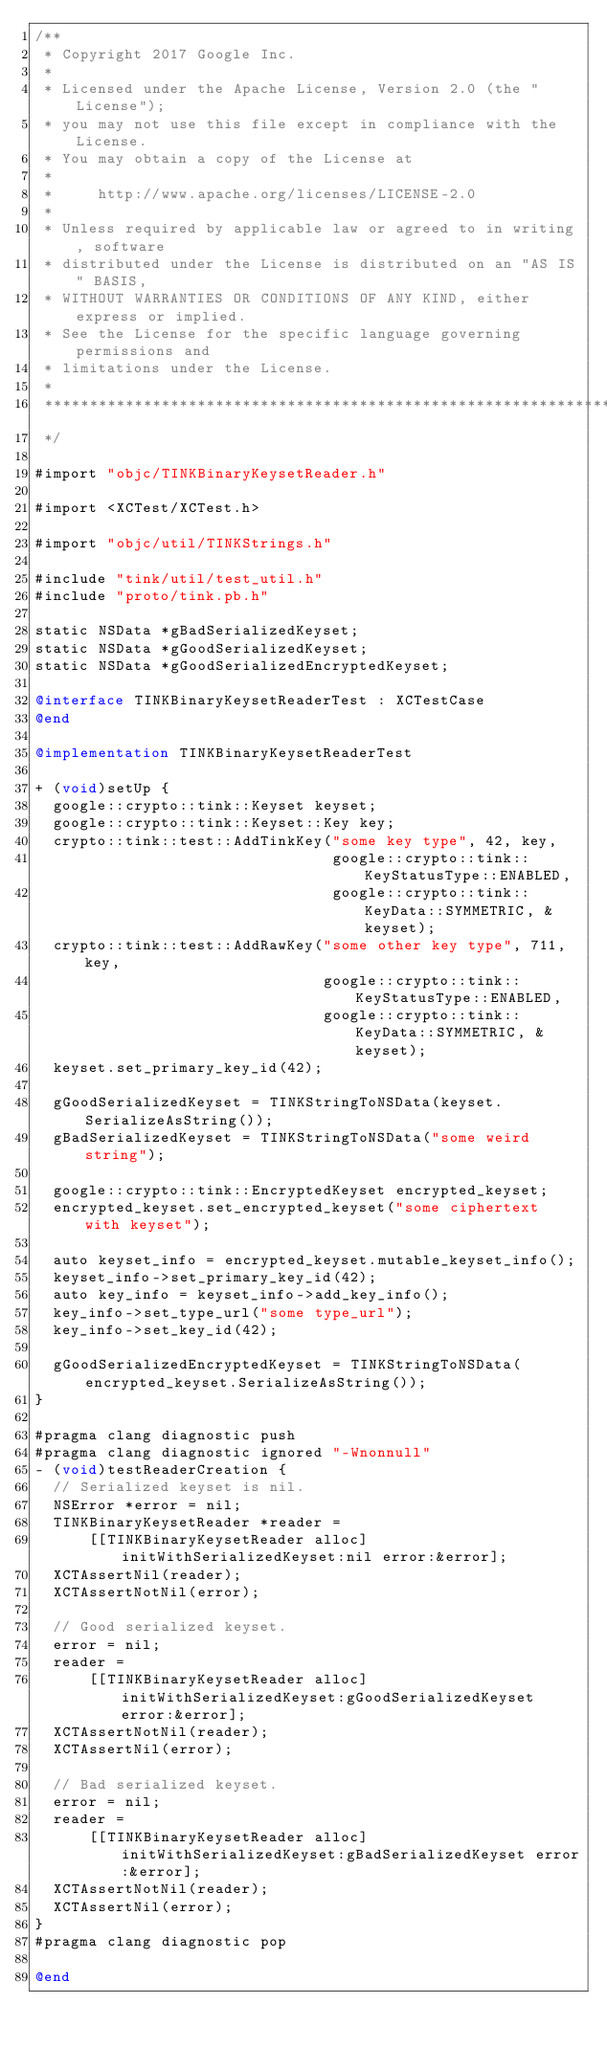Convert code to text. <code><loc_0><loc_0><loc_500><loc_500><_ObjectiveC_>/**
 * Copyright 2017 Google Inc.
 *
 * Licensed under the Apache License, Version 2.0 (the "License");
 * you may not use this file except in compliance with the License.
 * You may obtain a copy of the License at
 *
 *     http://www.apache.org/licenses/LICENSE-2.0
 *
 * Unless required by applicable law or agreed to in writing, software
 * distributed under the License is distributed on an "AS IS" BASIS,
 * WITHOUT WARRANTIES OR CONDITIONS OF ANY KIND, either express or implied.
 * See the License for the specific language governing permissions and
 * limitations under the License.
 *
 **************************************************************************
 */

#import "objc/TINKBinaryKeysetReader.h"

#import <XCTest/XCTest.h>

#import "objc/util/TINKStrings.h"

#include "tink/util/test_util.h"
#include "proto/tink.pb.h"

static NSData *gBadSerializedKeyset;
static NSData *gGoodSerializedKeyset;
static NSData *gGoodSerializedEncryptedKeyset;

@interface TINKBinaryKeysetReaderTest : XCTestCase
@end

@implementation TINKBinaryKeysetReaderTest

+ (void)setUp {
  google::crypto::tink::Keyset keyset;
  google::crypto::tink::Keyset::Key key;
  crypto::tink::test::AddTinkKey("some key type", 42, key,
                                 google::crypto::tink::KeyStatusType::ENABLED,
                                 google::crypto::tink::KeyData::SYMMETRIC, &keyset);
  crypto::tink::test::AddRawKey("some other key type", 711, key,
                                google::crypto::tink::KeyStatusType::ENABLED,
                                google::crypto::tink::KeyData::SYMMETRIC, &keyset);
  keyset.set_primary_key_id(42);

  gGoodSerializedKeyset = TINKStringToNSData(keyset.SerializeAsString());
  gBadSerializedKeyset = TINKStringToNSData("some weird string");

  google::crypto::tink::EncryptedKeyset encrypted_keyset;
  encrypted_keyset.set_encrypted_keyset("some ciphertext with keyset");

  auto keyset_info = encrypted_keyset.mutable_keyset_info();
  keyset_info->set_primary_key_id(42);
  auto key_info = keyset_info->add_key_info();
  key_info->set_type_url("some type_url");
  key_info->set_key_id(42);

  gGoodSerializedEncryptedKeyset = TINKStringToNSData(encrypted_keyset.SerializeAsString());
}

#pragma clang diagnostic push
#pragma clang diagnostic ignored "-Wnonnull"
- (void)testReaderCreation {
  // Serialized keyset is nil.
  NSError *error = nil;
  TINKBinaryKeysetReader *reader =
      [[TINKBinaryKeysetReader alloc] initWithSerializedKeyset:nil error:&error];
  XCTAssertNil(reader);
  XCTAssertNotNil(error);

  // Good serialized keyset.
  error = nil;
  reader =
      [[TINKBinaryKeysetReader alloc] initWithSerializedKeyset:gGoodSerializedKeyset error:&error];
  XCTAssertNotNil(reader);
  XCTAssertNil(error);

  // Bad serialized keyset.
  error = nil;
  reader =
      [[TINKBinaryKeysetReader alloc] initWithSerializedKeyset:gBadSerializedKeyset error:&error];
  XCTAssertNotNil(reader);
  XCTAssertNil(error);
}
#pragma clang diagnostic pop

@end
</code> 